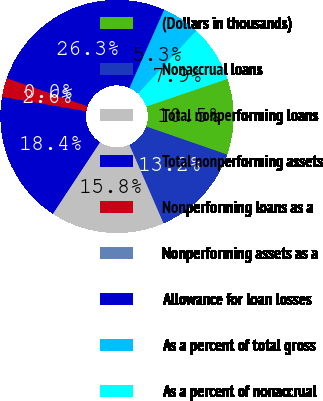<chart> <loc_0><loc_0><loc_500><loc_500><pie_chart><fcel>(Dollars in thousands)<fcel>Nonaccrual loans<fcel>Total nonperforming loans<fcel>Total nonperforming assets<fcel>Nonperforming loans as a<fcel>Nonperforming assets as a<fcel>Allowance for loan losses<fcel>As a percent of total gross<fcel>As a percent of nonaccrual<nl><fcel>10.53%<fcel>13.16%<fcel>15.79%<fcel>18.42%<fcel>2.63%<fcel>0.0%<fcel>26.32%<fcel>5.26%<fcel>7.89%<nl></chart> 